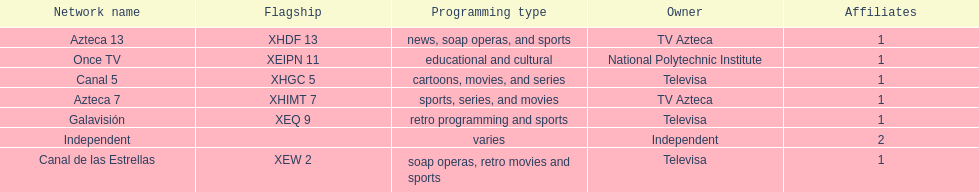What is the average number of affiliates that a given network will have? 1. 